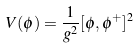<formula> <loc_0><loc_0><loc_500><loc_500>V ( \phi ) = { \frac { 1 } { g ^ { 2 } } } [ \phi , \phi ^ { + } ] ^ { 2 }</formula> 